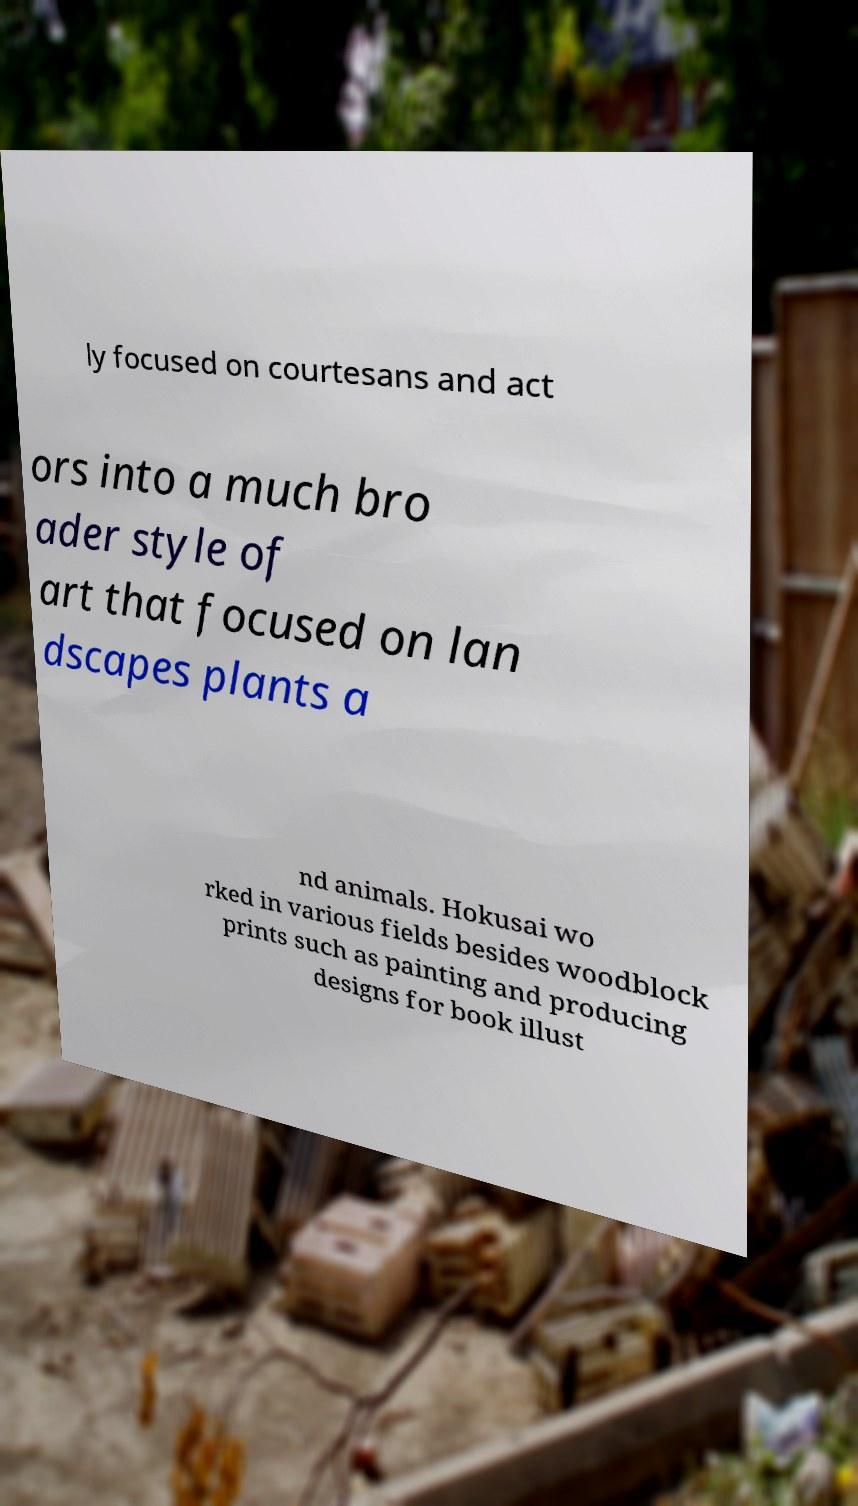There's text embedded in this image that I need extracted. Can you transcribe it verbatim? ly focused on courtesans and act ors into a much bro ader style of art that focused on lan dscapes plants a nd animals. Hokusai wo rked in various fields besides woodblock prints such as painting and producing designs for book illust 